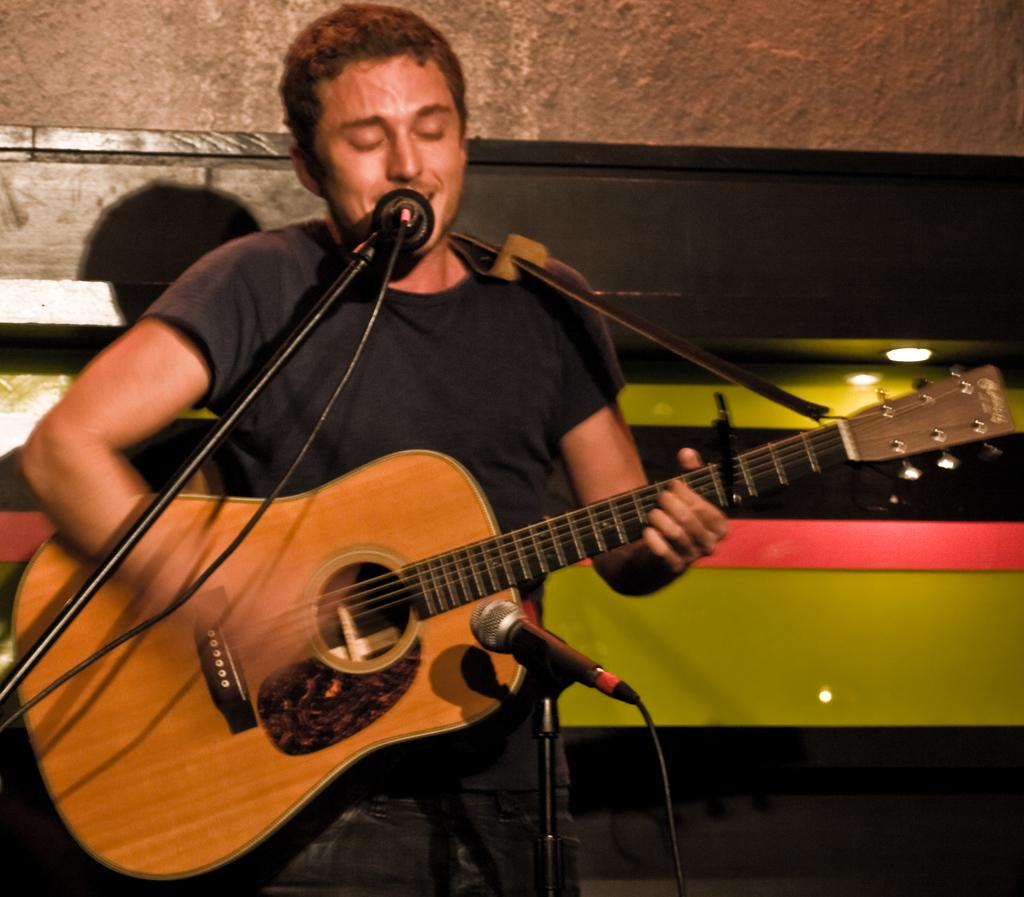What is the main subject of the image? The main subject of the image is a man. What is the man doing in the image? The man is standing in the image. What object is the man holding in his hand? The man is holding a guitar in his hand. What type of curtain can be seen hanging behind the man in the image? There is no curtain visible in the image; it only features a man standing and holding a guitar. 